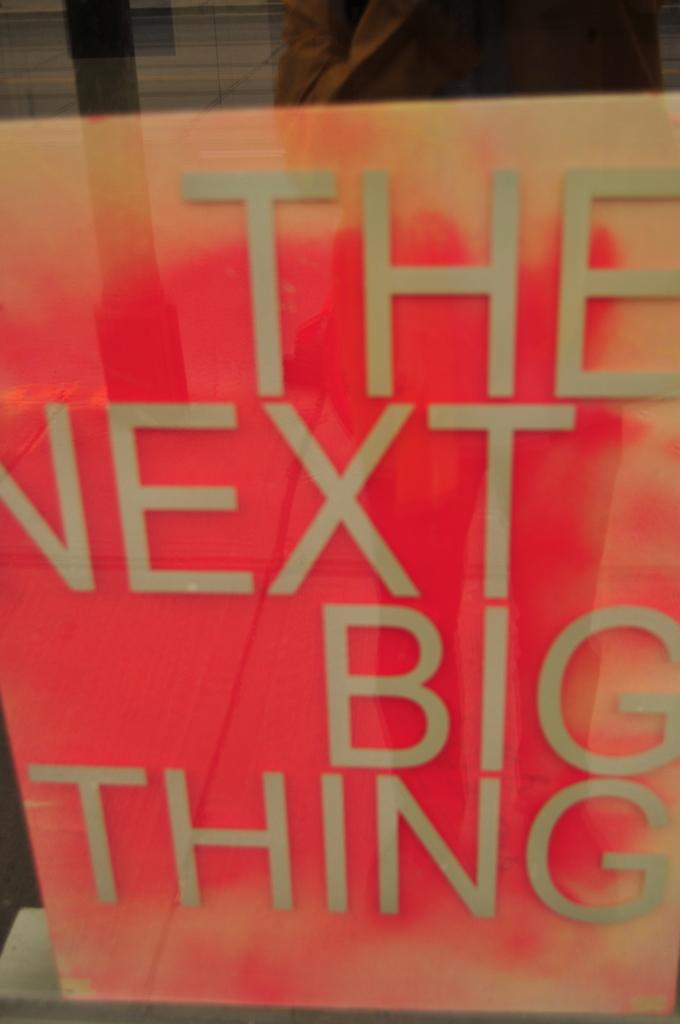What color are the letters?
Offer a terse response. Answering does not require reading text in the image. 